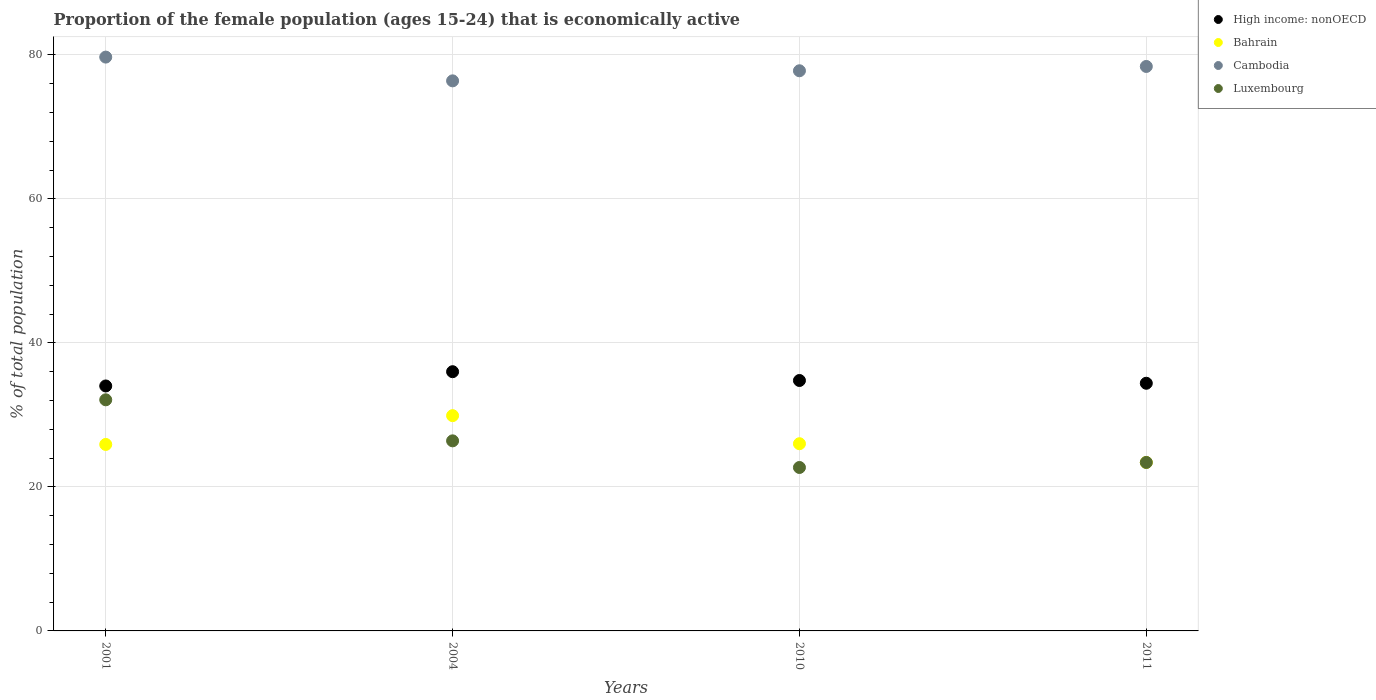Is the number of dotlines equal to the number of legend labels?
Ensure brevity in your answer.  Yes. What is the proportion of the female population that is economically active in Luxembourg in 2011?
Make the answer very short. 23.4. Across all years, what is the maximum proportion of the female population that is economically active in High income: nonOECD?
Your response must be concise. 36. Across all years, what is the minimum proportion of the female population that is economically active in High income: nonOECD?
Make the answer very short. 34.02. In which year was the proportion of the female population that is economically active in Cambodia minimum?
Your answer should be compact. 2004. What is the total proportion of the female population that is economically active in Luxembourg in the graph?
Your answer should be very brief. 104.6. What is the difference between the proportion of the female population that is economically active in Bahrain in 2004 and that in 2010?
Ensure brevity in your answer.  3.9. What is the difference between the proportion of the female population that is economically active in Bahrain in 2004 and the proportion of the female population that is economically active in Luxembourg in 2001?
Ensure brevity in your answer.  -2.2. What is the average proportion of the female population that is economically active in High income: nonOECD per year?
Give a very brief answer. 34.8. In the year 2001, what is the difference between the proportion of the female population that is economically active in Cambodia and proportion of the female population that is economically active in High income: nonOECD?
Keep it short and to the point. 45.68. What is the ratio of the proportion of the female population that is economically active in Luxembourg in 2004 to that in 2011?
Provide a short and direct response. 1.13. What is the difference between the highest and the second highest proportion of the female population that is economically active in Luxembourg?
Ensure brevity in your answer.  5.7. What is the difference between the highest and the lowest proportion of the female population that is economically active in High income: nonOECD?
Offer a terse response. 1.98. Is it the case that in every year, the sum of the proportion of the female population that is economically active in Luxembourg and proportion of the female population that is economically active in High income: nonOECD  is greater than the proportion of the female population that is economically active in Bahrain?
Provide a short and direct response. Yes. Is the proportion of the female population that is economically active in Cambodia strictly greater than the proportion of the female population that is economically active in High income: nonOECD over the years?
Make the answer very short. Yes. Is the proportion of the female population that is economically active in Bahrain strictly less than the proportion of the female population that is economically active in Luxembourg over the years?
Offer a terse response. No. How many years are there in the graph?
Your answer should be compact. 4. Are the values on the major ticks of Y-axis written in scientific E-notation?
Offer a very short reply. No. How are the legend labels stacked?
Your response must be concise. Vertical. What is the title of the graph?
Keep it short and to the point. Proportion of the female population (ages 15-24) that is economically active. What is the label or title of the X-axis?
Keep it short and to the point. Years. What is the label or title of the Y-axis?
Offer a terse response. % of total population. What is the % of total population in High income: nonOECD in 2001?
Keep it short and to the point. 34.02. What is the % of total population of Bahrain in 2001?
Ensure brevity in your answer.  25.9. What is the % of total population of Cambodia in 2001?
Offer a terse response. 79.7. What is the % of total population in Luxembourg in 2001?
Offer a terse response. 32.1. What is the % of total population in High income: nonOECD in 2004?
Offer a terse response. 36. What is the % of total population in Bahrain in 2004?
Make the answer very short. 29.9. What is the % of total population of Cambodia in 2004?
Your answer should be compact. 76.4. What is the % of total population of Luxembourg in 2004?
Your answer should be very brief. 26.4. What is the % of total population of High income: nonOECD in 2010?
Offer a very short reply. 34.78. What is the % of total population in Cambodia in 2010?
Give a very brief answer. 77.8. What is the % of total population in Luxembourg in 2010?
Offer a very short reply. 22.7. What is the % of total population of High income: nonOECD in 2011?
Your response must be concise. 34.4. What is the % of total population of Bahrain in 2011?
Keep it short and to the point. 23.4. What is the % of total population in Cambodia in 2011?
Give a very brief answer. 78.4. What is the % of total population of Luxembourg in 2011?
Keep it short and to the point. 23.4. Across all years, what is the maximum % of total population in High income: nonOECD?
Your response must be concise. 36. Across all years, what is the maximum % of total population of Bahrain?
Ensure brevity in your answer.  29.9. Across all years, what is the maximum % of total population in Cambodia?
Offer a very short reply. 79.7. Across all years, what is the maximum % of total population in Luxembourg?
Keep it short and to the point. 32.1. Across all years, what is the minimum % of total population of High income: nonOECD?
Offer a very short reply. 34.02. Across all years, what is the minimum % of total population of Bahrain?
Your response must be concise. 23.4. Across all years, what is the minimum % of total population of Cambodia?
Your answer should be compact. 76.4. Across all years, what is the minimum % of total population of Luxembourg?
Offer a very short reply. 22.7. What is the total % of total population in High income: nonOECD in the graph?
Keep it short and to the point. 139.21. What is the total % of total population of Bahrain in the graph?
Offer a very short reply. 105.2. What is the total % of total population in Cambodia in the graph?
Your response must be concise. 312.3. What is the total % of total population of Luxembourg in the graph?
Provide a short and direct response. 104.6. What is the difference between the % of total population of High income: nonOECD in 2001 and that in 2004?
Offer a terse response. -1.98. What is the difference between the % of total population of Bahrain in 2001 and that in 2004?
Provide a succinct answer. -4. What is the difference between the % of total population of Cambodia in 2001 and that in 2004?
Your response must be concise. 3.3. What is the difference between the % of total population in Luxembourg in 2001 and that in 2004?
Your answer should be very brief. 5.7. What is the difference between the % of total population in High income: nonOECD in 2001 and that in 2010?
Offer a very short reply. -0.76. What is the difference between the % of total population in Luxembourg in 2001 and that in 2010?
Provide a succinct answer. 9.4. What is the difference between the % of total population in High income: nonOECD in 2001 and that in 2011?
Provide a succinct answer. -0.38. What is the difference between the % of total population in Bahrain in 2001 and that in 2011?
Your answer should be very brief. 2.5. What is the difference between the % of total population of Cambodia in 2001 and that in 2011?
Offer a terse response. 1.3. What is the difference between the % of total population of Luxembourg in 2001 and that in 2011?
Keep it short and to the point. 8.7. What is the difference between the % of total population of High income: nonOECD in 2004 and that in 2010?
Give a very brief answer. 1.22. What is the difference between the % of total population of Cambodia in 2004 and that in 2010?
Keep it short and to the point. -1.4. What is the difference between the % of total population of Luxembourg in 2004 and that in 2010?
Provide a short and direct response. 3.7. What is the difference between the % of total population in High income: nonOECD in 2004 and that in 2011?
Provide a succinct answer. 1.61. What is the difference between the % of total population of High income: nonOECD in 2010 and that in 2011?
Your answer should be compact. 0.38. What is the difference between the % of total population in Bahrain in 2010 and that in 2011?
Offer a very short reply. 2.6. What is the difference between the % of total population in High income: nonOECD in 2001 and the % of total population in Bahrain in 2004?
Your response must be concise. 4.12. What is the difference between the % of total population of High income: nonOECD in 2001 and the % of total population of Cambodia in 2004?
Give a very brief answer. -42.38. What is the difference between the % of total population of High income: nonOECD in 2001 and the % of total population of Luxembourg in 2004?
Offer a very short reply. 7.62. What is the difference between the % of total population in Bahrain in 2001 and the % of total population in Cambodia in 2004?
Provide a succinct answer. -50.5. What is the difference between the % of total population in Bahrain in 2001 and the % of total population in Luxembourg in 2004?
Ensure brevity in your answer.  -0.5. What is the difference between the % of total population in Cambodia in 2001 and the % of total population in Luxembourg in 2004?
Provide a short and direct response. 53.3. What is the difference between the % of total population in High income: nonOECD in 2001 and the % of total population in Bahrain in 2010?
Your answer should be very brief. 8.02. What is the difference between the % of total population in High income: nonOECD in 2001 and the % of total population in Cambodia in 2010?
Keep it short and to the point. -43.78. What is the difference between the % of total population in High income: nonOECD in 2001 and the % of total population in Luxembourg in 2010?
Your answer should be very brief. 11.32. What is the difference between the % of total population in Bahrain in 2001 and the % of total population in Cambodia in 2010?
Ensure brevity in your answer.  -51.9. What is the difference between the % of total population in Cambodia in 2001 and the % of total population in Luxembourg in 2010?
Provide a succinct answer. 57. What is the difference between the % of total population of High income: nonOECD in 2001 and the % of total population of Bahrain in 2011?
Make the answer very short. 10.62. What is the difference between the % of total population in High income: nonOECD in 2001 and the % of total population in Cambodia in 2011?
Provide a short and direct response. -44.38. What is the difference between the % of total population in High income: nonOECD in 2001 and the % of total population in Luxembourg in 2011?
Provide a succinct answer. 10.62. What is the difference between the % of total population in Bahrain in 2001 and the % of total population in Cambodia in 2011?
Provide a succinct answer. -52.5. What is the difference between the % of total population in Cambodia in 2001 and the % of total population in Luxembourg in 2011?
Your answer should be very brief. 56.3. What is the difference between the % of total population of High income: nonOECD in 2004 and the % of total population of Bahrain in 2010?
Make the answer very short. 10. What is the difference between the % of total population in High income: nonOECD in 2004 and the % of total population in Cambodia in 2010?
Make the answer very short. -41.8. What is the difference between the % of total population in High income: nonOECD in 2004 and the % of total population in Luxembourg in 2010?
Keep it short and to the point. 13.3. What is the difference between the % of total population of Bahrain in 2004 and the % of total population of Cambodia in 2010?
Ensure brevity in your answer.  -47.9. What is the difference between the % of total population in Cambodia in 2004 and the % of total population in Luxembourg in 2010?
Your response must be concise. 53.7. What is the difference between the % of total population of High income: nonOECD in 2004 and the % of total population of Bahrain in 2011?
Your answer should be very brief. 12.6. What is the difference between the % of total population of High income: nonOECD in 2004 and the % of total population of Cambodia in 2011?
Ensure brevity in your answer.  -42.4. What is the difference between the % of total population in High income: nonOECD in 2004 and the % of total population in Luxembourg in 2011?
Give a very brief answer. 12.6. What is the difference between the % of total population of Bahrain in 2004 and the % of total population of Cambodia in 2011?
Make the answer very short. -48.5. What is the difference between the % of total population of Cambodia in 2004 and the % of total population of Luxembourg in 2011?
Your response must be concise. 53. What is the difference between the % of total population in High income: nonOECD in 2010 and the % of total population in Bahrain in 2011?
Make the answer very short. 11.38. What is the difference between the % of total population of High income: nonOECD in 2010 and the % of total population of Cambodia in 2011?
Keep it short and to the point. -43.62. What is the difference between the % of total population of High income: nonOECD in 2010 and the % of total population of Luxembourg in 2011?
Offer a very short reply. 11.38. What is the difference between the % of total population in Bahrain in 2010 and the % of total population in Cambodia in 2011?
Your answer should be compact. -52.4. What is the difference between the % of total population in Bahrain in 2010 and the % of total population in Luxembourg in 2011?
Give a very brief answer. 2.6. What is the difference between the % of total population in Cambodia in 2010 and the % of total population in Luxembourg in 2011?
Provide a succinct answer. 54.4. What is the average % of total population of High income: nonOECD per year?
Keep it short and to the point. 34.8. What is the average % of total population of Bahrain per year?
Ensure brevity in your answer.  26.3. What is the average % of total population of Cambodia per year?
Offer a terse response. 78.08. What is the average % of total population in Luxembourg per year?
Make the answer very short. 26.15. In the year 2001, what is the difference between the % of total population in High income: nonOECD and % of total population in Bahrain?
Keep it short and to the point. 8.12. In the year 2001, what is the difference between the % of total population in High income: nonOECD and % of total population in Cambodia?
Your answer should be very brief. -45.68. In the year 2001, what is the difference between the % of total population of High income: nonOECD and % of total population of Luxembourg?
Give a very brief answer. 1.92. In the year 2001, what is the difference between the % of total population in Bahrain and % of total population in Cambodia?
Your answer should be very brief. -53.8. In the year 2001, what is the difference between the % of total population in Cambodia and % of total population in Luxembourg?
Keep it short and to the point. 47.6. In the year 2004, what is the difference between the % of total population of High income: nonOECD and % of total population of Bahrain?
Provide a succinct answer. 6.1. In the year 2004, what is the difference between the % of total population in High income: nonOECD and % of total population in Cambodia?
Provide a short and direct response. -40.4. In the year 2004, what is the difference between the % of total population of High income: nonOECD and % of total population of Luxembourg?
Your answer should be compact. 9.6. In the year 2004, what is the difference between the % of total population of Bahrain and % of total population of Cambodia?
Ensure brevity in your answer.  -46.5. In the year 2004, what is the difference between the % of total population of Bahrain and % of total population of Luxembourg?
Provide a succinct answer. 3.5. In the year 2010, what is the difference between the % of total population in High income: nonOECD and % of total population in Bahrain?
Your answer should be compact. 8.78. In the year 2010, what is the difference between the % of total population of High income: nonOECD and % of total population of Cambodia?
Provide a short and direct response. -43.02. In the year 2010, what is the difference between the % of total population of High income: nonOECD and % of total population of Luxembourg?
Your answer should be compact. 12.08. In the year 2010, what is the difference between the % of total population in Bahrain and % of total population in Cambodia?
Give a very brief answer. -51.8. In the year 2010, what is the difference between the % of total population of Bahrain and % of total population of Luxembourg?
Your response must be concise. 3.3. In the year 2010, what is the difference between the % of total population of Cambodia and % of total population of Luxembourg?
Your response must be concise. 55.1. In the year 2011, what is the difference between the % of total population of High income: nonOECD and % of total population of Bahrain?
Keep it short and to the point. 11. In the year 2011, what is the difference between the % of total population of High income: nonOECD and % of total population of Cambodia?
Provide a short and direct response. -44. In the year 2011, what is the difference between the % of total population of High income: nonOECD and % of total population of Luxembourg?
Offer a terse response. 11. In the year 2011, what is the difference between the % of total population of Bahrain and % of total population of Cambodia?
Offer a very short reply. -55. In the year 2011, what is the difference between the % of total population of Bahrain and % of total population of Luxembourg?
Make the answer very short. 0. What is the ratio of the % of total population of High income: nonOECD in 2001 to that in 2004?
Give a very brief answer. 0.94. What is the ratio of the % of total population in Bahrain in 2001 to that in 2004?
Provide a short and direct response. 0.87. What is the ratio of the % of total population of Cambodia in 2001 to that in 2004?
Provide a succinct answer. 1.04. What is the ratio of the % of total population of Luxembourg in 2001 to that in 2004?
Ensure brevity in your answer.  1.22. What is the ratio of the % of total population of High income: nonOECD in 2001 to that in 2010?
Offer a terse response. 0.98. What is the ratio of the % of total population in Bahrain in 2001 to that in 2010?
Give a very brief answer. 1. What is the ratio of the % of total population in Cambodia in 2001 to that in 2010?
Provide a succinct answer. 1.02. What is the ratio of the % of total population of Luxembourg in 2001 to that in 2010?
Offer a terse response. 1.41. What is the ratio of the % of total population of High income: nonOECD in 2001 to that in 2011?
Provide a short and direct response. 0.99. What is the ratio of the % of total population of Bahrain in 2001 to that in 2011?
Offer a very short reply. 1.11. What is the ratio of the % of total population of Cambodia in 2001 to that in 2011?
Provide a succinct answer. 1.02. What is the ratio of the % of total population of Luxembourg in 2001 to that in 2011?
Your answer should be compact. 1.37. What is the ratio of the % of total population of High income: nonOECD in 2004 to that in 2010?
Offer a terse response. 1.04. What is the ratio of the % of total population in Bahrain in 2004 to that in 2010?
Ensure brevity in your answer.  1.15. What is the ratio of the % of total population in Cambodia in 2004 to that in 2010?
Your answer should be compact. 0.98. What is the ratio of the % of total population of Luxembourg in 2004 to that in 2010?
Your answer should be compact. 1.16. What is the ratio of the % of total population of High income: nonOECD in 2004 to that in 2011?
Your answer should be compact. 1.05. What is the ratio of the % of total population of Bahrain in 2004 to that in 2011?
Keep it short and to the point. 1.28. What is the ratio of the % of total population of Cambodia in 2004 to that in 2011?
Offer a terse response. 0.97. What is the ratio of the % of total population of Luxembourg in 2004 to that in 2011?
Your answer should be very brief. 1.13. What is the ratio of the % of total population of High income: nonOECD in 2010 to that in 2011?
Offer a terse response. 1.01. What is the ratio of the % of total population in Bahrain in 2010 to that in 2011?
Offer a very short reply. 1.11. What is the ratio of the % of total population in Cambodia in 2010 to that in 2011?
Keep it short and to the point. 0.99. What is the ratio of the % of total population of Luxembourg in 2010 to that in 2011?
Keep it short and to the point. 0.97. What is the difference between the highest and the second highest % of total population in High income: nonOECD?
Offer a very short reply. 1.22. What is the difference between the highest and the second highest % of total population in Cambodia?
Offer a very short reply. 1.3. What is the difference between the highest and the lowest % of total population in High income: nonOECD?
Your answer should be compact. 1.98. What is the difference between the highest and the lowest % of total population of Cambodia?
Offer a very short reply. 3.3. What is the difference between the highest and the lowest % of total population in Luxembourg?
Your answer should be compact. 9.4. 